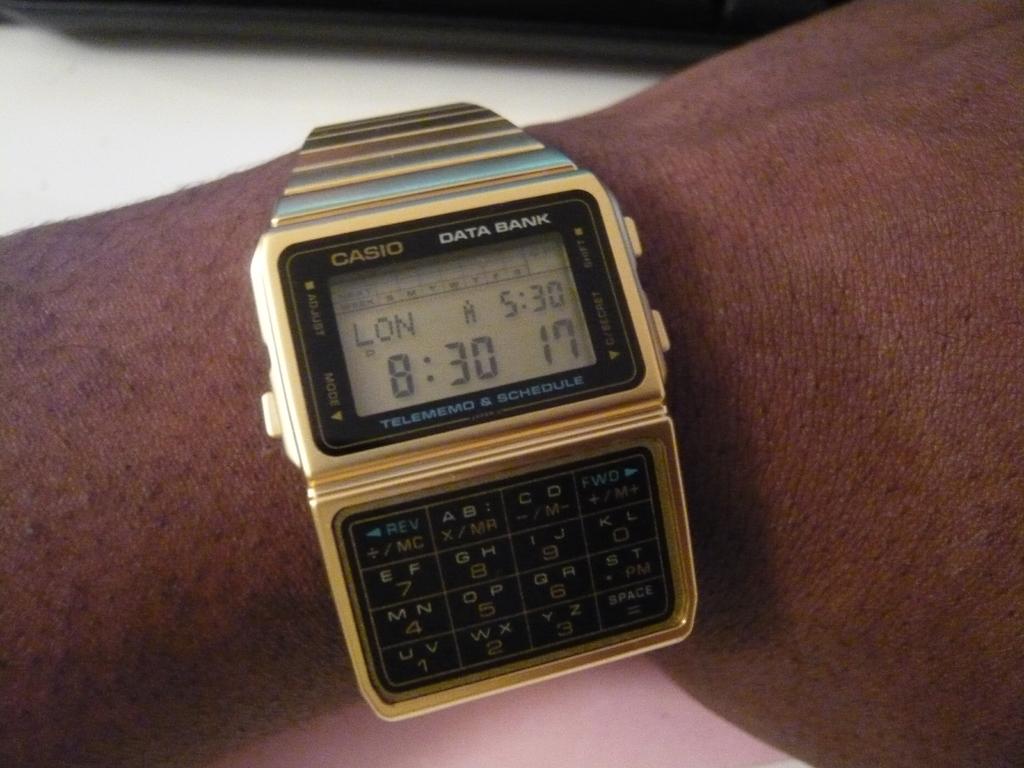What brand of watch is shown?
Ensure brevity in your answer.  Casio. What time is it?
Give a very brief answer. 8:30. 